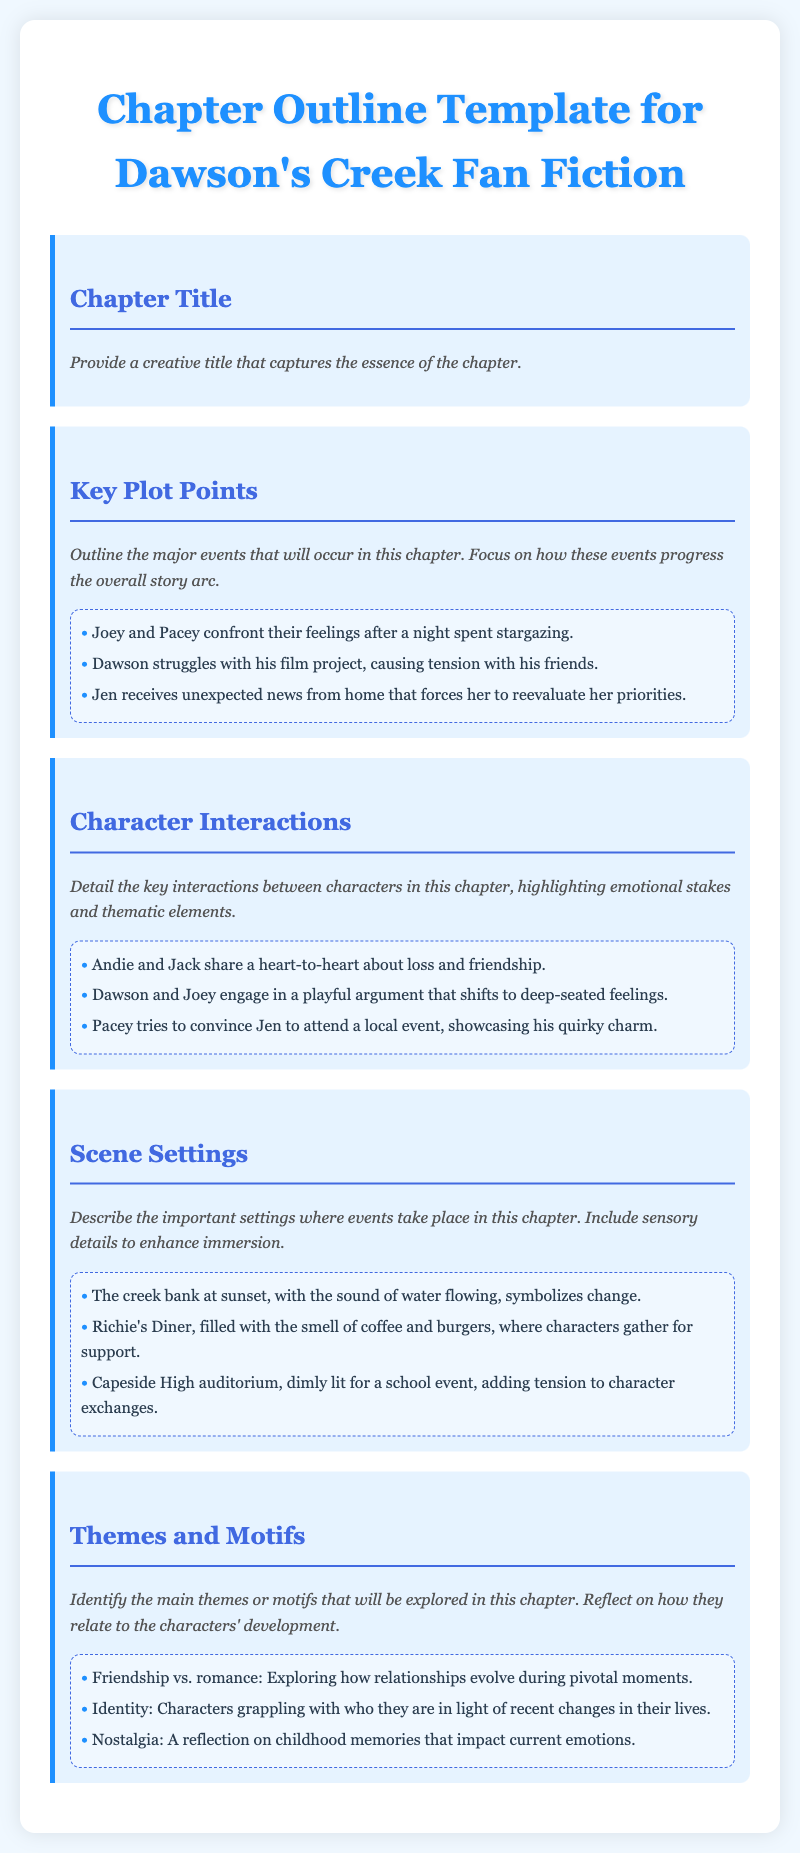What is the title of the document? The title of the document is stated at the beginning and indicates that it is a template for chapter outlines specifically for fan fiction related to Dawson's Creek.
Answer: Chapter Outline Template for Dawson's Creek Fan Fiction What is one example of a key plot point? The document provides examples of key plot points that involve character interactions and developments throughout the chapter.
Answer: Joey and Pacey confront their feelings after a night spent stargazing What are character interactions meant to highlight? The section on character interactions focuses on emotional stakes and thematic elements that occur between characters.
Answer: Emotional stakes and thematic elements What type of food is mentioned in the scene settings? In the settings section, specific food items associated with a character gathering place are listed.
Answer: Coffee and burgers What theme explores the evolution of relationships? The document outlines themes that delve into various aspects of character relationships, one of them focuses on the conflict between friendship and romantic feelings.
Answer: Friendship vs. romance What setting symbolizes change? The sensory details in the scene settings provide imagery that signifies thematic elements related to change within the narrative.
Answer: The creek bank at sunset How many example character interactions are provided? The document provides a specific number of examples for character interactions to emphasize key moments between characters.
Answer: Three What does the document suggest is necessary when outlining key plot points? The document emphasizes a focus on how plot points progress the overall story arc during chapter development.
Answer: Progress the overall story arc 